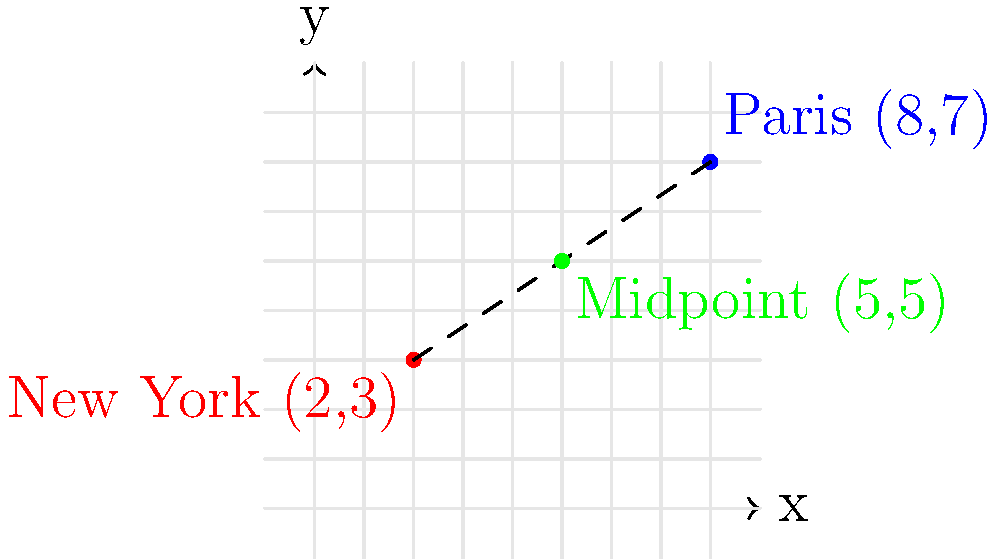As a fashionista preparing for a global fashion tour inspired by Michael Jordan's worldwide influence, you're planning to attend Fashion Weeks in New York and Paris. On the coordinate system, New York Fashion Week is located at (2,3) and Paris Fashion Week is at (8,7). What are the coordinates of the midpoint between these two fashion capitals? To find the midpoint between two points on a coordinate system, we can follow these steps:

1. Identify the coordinates of the two points:
   - New York: $(x_1, y_1) = (2, 3)$
   - Paris: $(x_2, y_2) = (8, 7)$

2. Use the midpoint formula:
   $(\frac{x_1 + x_2}{2}, \frac{y_1 + y_2}{2})$

3. Calculate the x-coordinate of the midpoint:
   $\frac{x_1 + x_2}{2} = \frac{2 + 8}{2} = \frac{10}{2} = 5$

4. Calculate the y-coordinate of the midpoint:
   $\frac{y_1 + y_2}{2} = \frac{3 + 7}{2} = \frac{10}{2} = 5$

5. Combine the results:
   The midpoint coordinates are $(5, 5)$

This point represents the average location between New York and Paris on our fashion tour map, much like how Michael Jordan's influence bridged different basketball cultures around the world.
Answer: (5, 5) 